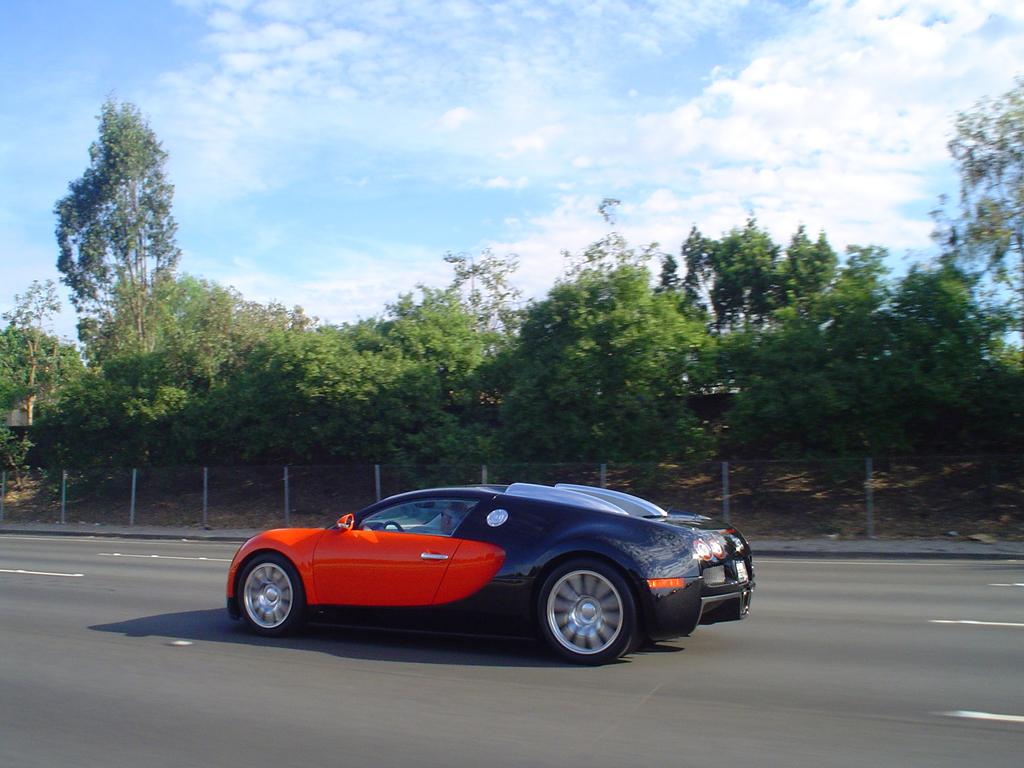Where was the image taken? The image was taken outside on the road. What can be seen on the road in the image? Cars are visible on the road. Are the cars stationary or moving in the image? The cars appear to be moving in the image. What is visible in the background of the image? There is a sky, trees, and a fence visible in the background. What type of behavior can be observed in the plants in the image? There are no plants present in the image, so it is not possible to observe any behavior. 